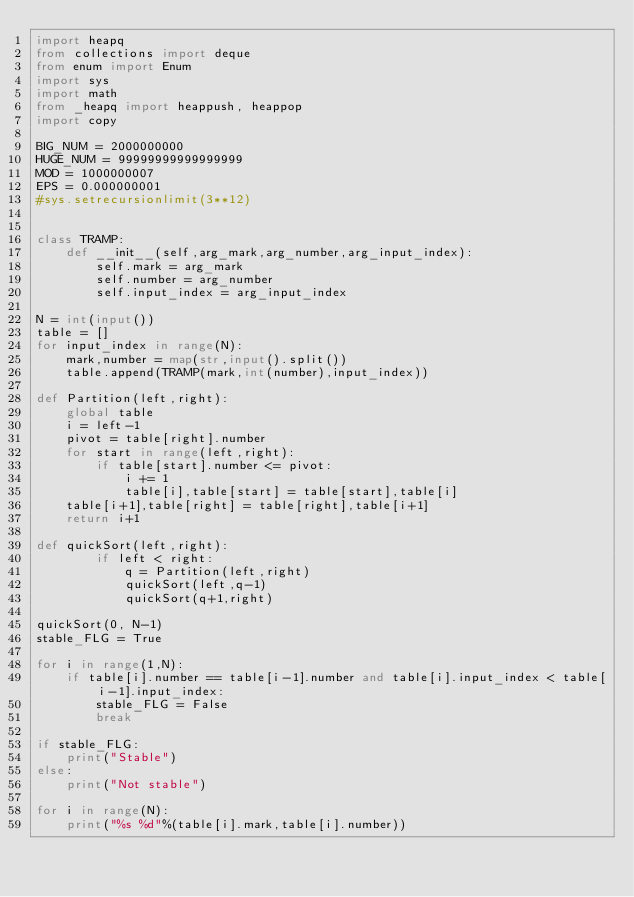Convert code to text. <code><loc_0><loc_0><loc_500><loc_500><_Python_>import heapq
from collections import deque
from enum import Enum
import sys
import math
from _heapq import heappush, heappop
import copy

BIG_NUM = 2000000000
HUGE_NUM = 99999999999999999
MOD = 1000000007
EPS = 0.000000001
#sys.setrecursionlimit(3**12)


class TRAMP:
    def __init__(self,arg_mark,arg_number,arg_input_index):
        self.mark = arg_mark
        self.number = arg_number
        self.input_index = arg_input_index

N = int(input())
table = []
for input_index in range(N):
    mark,number = map(str,input().split())
    table.append(TRAMP(mark,int(number),input_index))

def Partition(left,right):
    global table
    i = left-1
    pivot = table[right].number
    for start in range(left,right):
        if table[start].number <= pivot:
            i += 1
            table[i],table[start] = table[start],table[i]
    table[i+1],table[right] = table[right],table[i+1]
    return i+1

def quickSort(left,right):
        if left < right:
            q = Partition(left,right)
            quickSort(left,q-1)
            quickSort(q+1,right)

quickSort(0, N-1)
stable_FLG = True

for i in range(1,N):
    if table[i].number == table[i-1].number and table[i].input_index < table[i-1].input_index:
        stable_FLG = False
        break

if stable_FLG:
    print("Stable")
else:
    print("Not stable")

for i in range(N):
    print("%s %d"%(table[i].mark,table[i].number))


</code> 